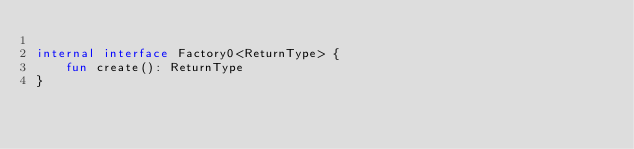Convert code to text. <code><loc_0><loc_0><loc_500><loc_500><_Kotlin_>
internal interface Factory0<ReturnType> {
    fun create(): ReturnType
}
</code> 